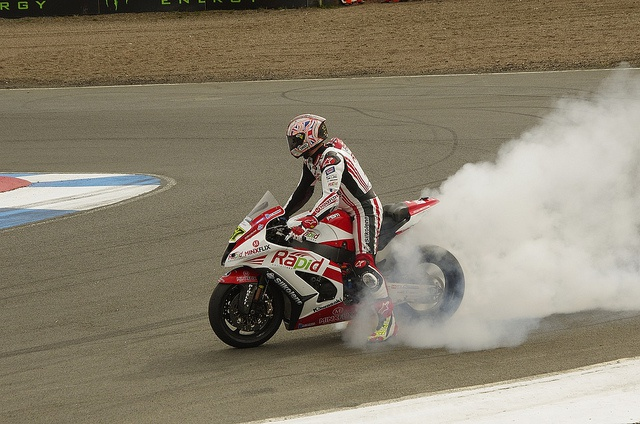Describe the objects in this image and their specific colors. I can see motorcycle in black, darkgray, gray, and maroon tones and people in black, darkgray, gray, and lightgray tones in this image. 